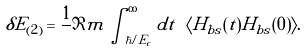<formula> <loc_0><loc_0><loc_500><loc_500>\delta E _ { ( 2 ) } = \frac { 1 } { } \Im m \int _ { \hbar { / } E _ { c } } ^ { \infty } d t \ \langle H _ { b s } ( t ) H _ { b s } ( 0 ) \rangle .</formula> 